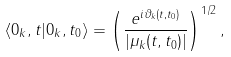<formula> <loc_0><loc_0><loc_500><loc_500>\langle 0 _ { k } , t | 0 _ { k } , t _ { 0 } \rangle = \left ( \frac { e ^ { i \vartheta _ { k } ( t , t _ { 0 } ) } } { | \mu _ { k } ( t , t _ { 0 } ) | } \right ) ^ { 1 / 2 } ,</formula> 